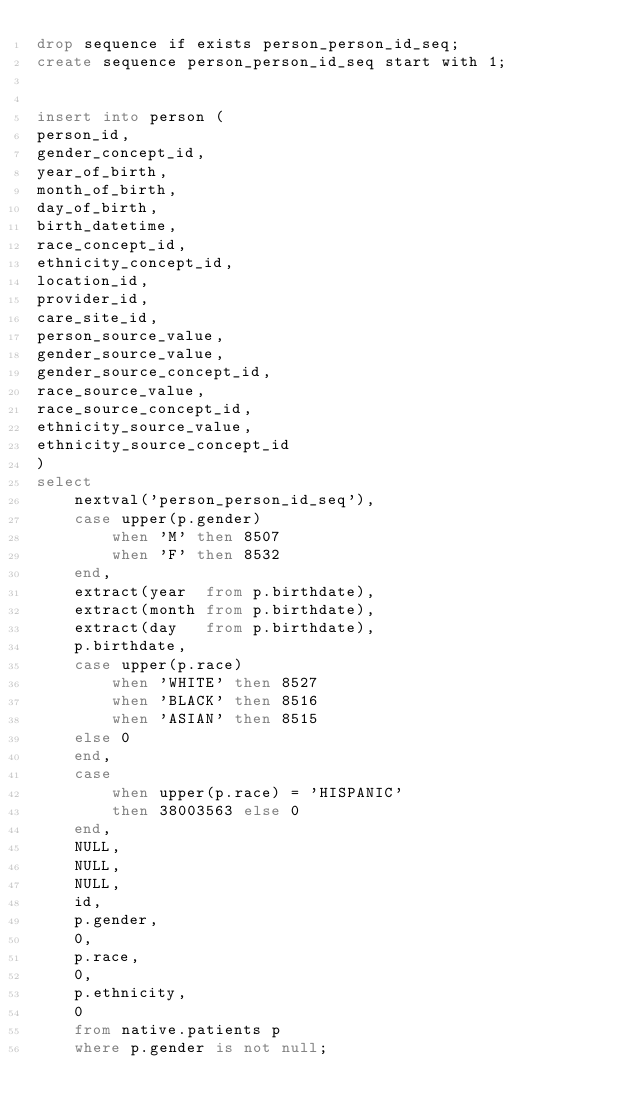Convert code to text. <code><loc_0><loc_0><loc_500><loc_500><_SQL_>drop sequence if exists person_person_id_seq;
create sequence person_person_id_seq start with 1;


insert into person (
person_id,                        
gender_concept_id,
year_of_birth,
month_of_birth,
day_of_birth,
birth_datetime,
race_concept_id,
ethnicity_concept_id,
location_id,
provider_id,
care_site_id,
person_source_value,
gender_source_value,
gender_source_concept_id,
race_source_value,
race_source_concept_id,
ethnicity_source_value,
ethnicity_source_concept_id
)
select
	nextval('person_person_id_seq'),   
	case upper(p.gender)
		when 'M' then 8507
		when 'F' then 8532
	end,                               
	extract(year  from p.birthdate),  
	extract(month from p.birthdate),  
	extract(day   from p.birthdate),  
	p.birthdate,                   
	case upper(p.race)             
		when 'WHITE' then 8527
		when 'BLACK' then 8516
		when 'ASIAN' then 8515
	else 0
	end,
	case 
		when upper(p.race) = 'HISPANIC'  
		then 38003563 else 0 
	end,      
	NULL,							
	NULL,                         
	NULL,                          
	id,                            
	p.gender,                      
	0,                              
	p.race,                       
	0,                        
	p.ethnicity,                 
	0                             
	from native.patients p
	where p.gender is not null;
</code> 